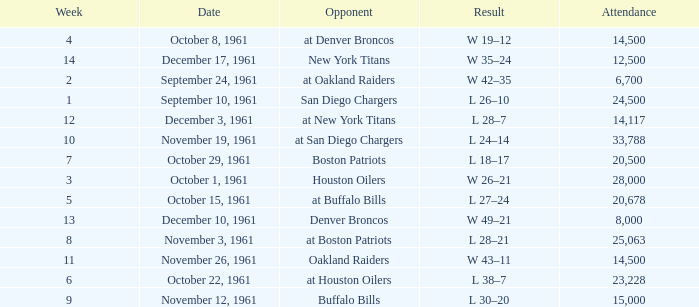What is the low attendance rate against buffalo bills? 15000.0. 